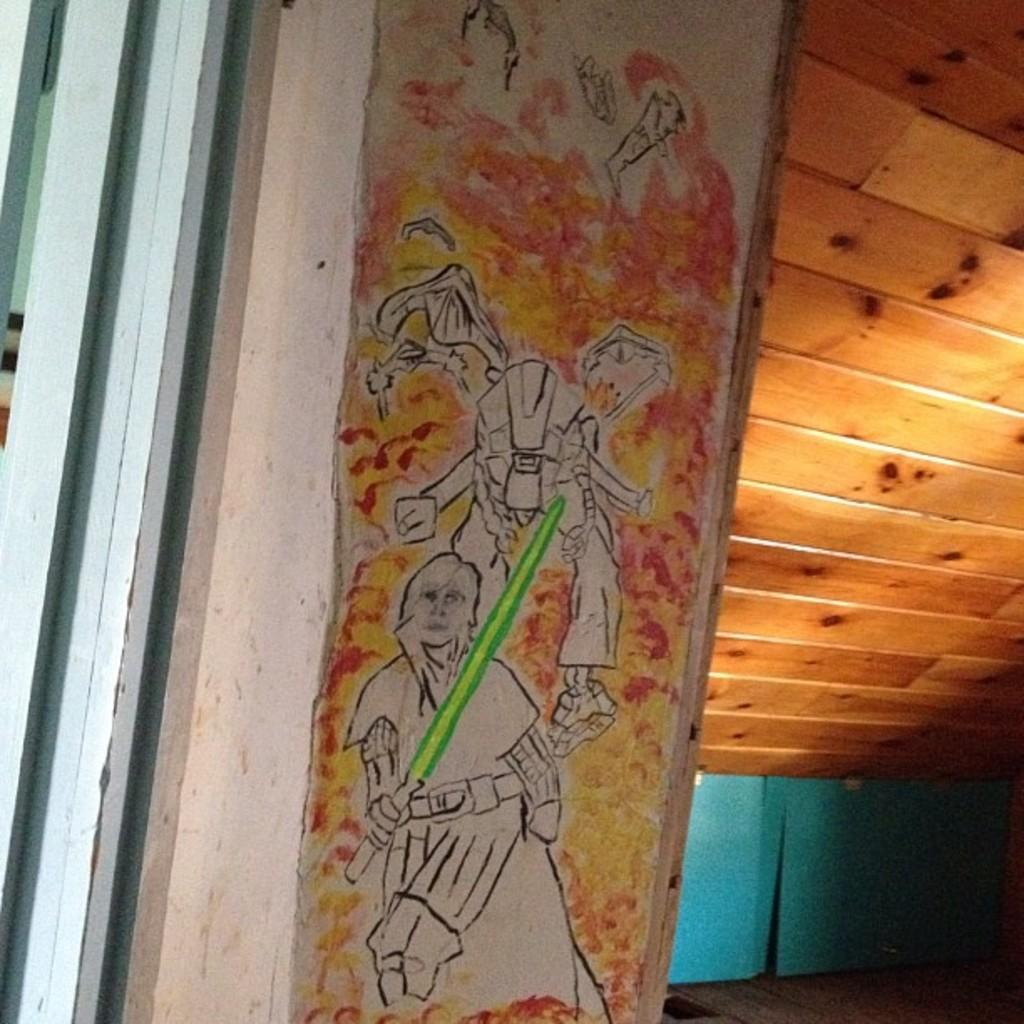What is depicted on the wall in the image? There is a painting on the wall in the image. What material is used for the roof on the right side of the image? The roof on the right side of the image is made up of wood. What color is the wall on the left side of the image? There is a wall in green color in the image. Can you push the wall with the painting to reveal a hidden curtain? There is no mention of a hidden curtain in the image, and the wall cannot be pushed as it is a static element in the image. 